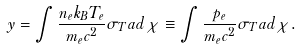Convert formula to latex. <formula><loc_0><loc_0><loc_500><loc_500>y = \int \frac { n _ { e } k _ { B } T _ { e } } { m _ { e } c ^ { 2 } } \sigma _ { T } a d \chi \equiv \int \frac { p _ { e } } { m _ { e } c ^ { 2 } } \sigma _ { T } a d \chi .</formula> 